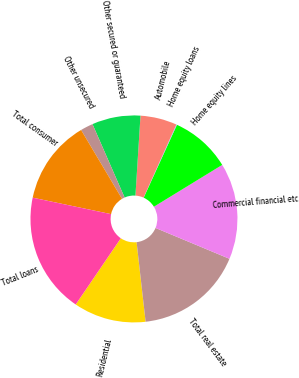<chart> <loc_0><loc_0><loc_500><loc_500><pie_chart><fcel>Residential<fcel>Total real estate<fcel>Commercial financial etc<fcel>Home equity lines<fcel>Home equity loans<fcel>Automobile<fcel>Other secured or guaranteed<fcel>Other unsecured<fcel>Total consumer<fcel>Total loans<nl><fcel>11.31%<fcel>16.91%<fcel>15.04%<fcel>9.44%<fcel>0.1%<fcel>5.71%<fcel>7.57%<fcel>1.97%<fcel>13.17%<fcel>18.78%<nl></chart> 